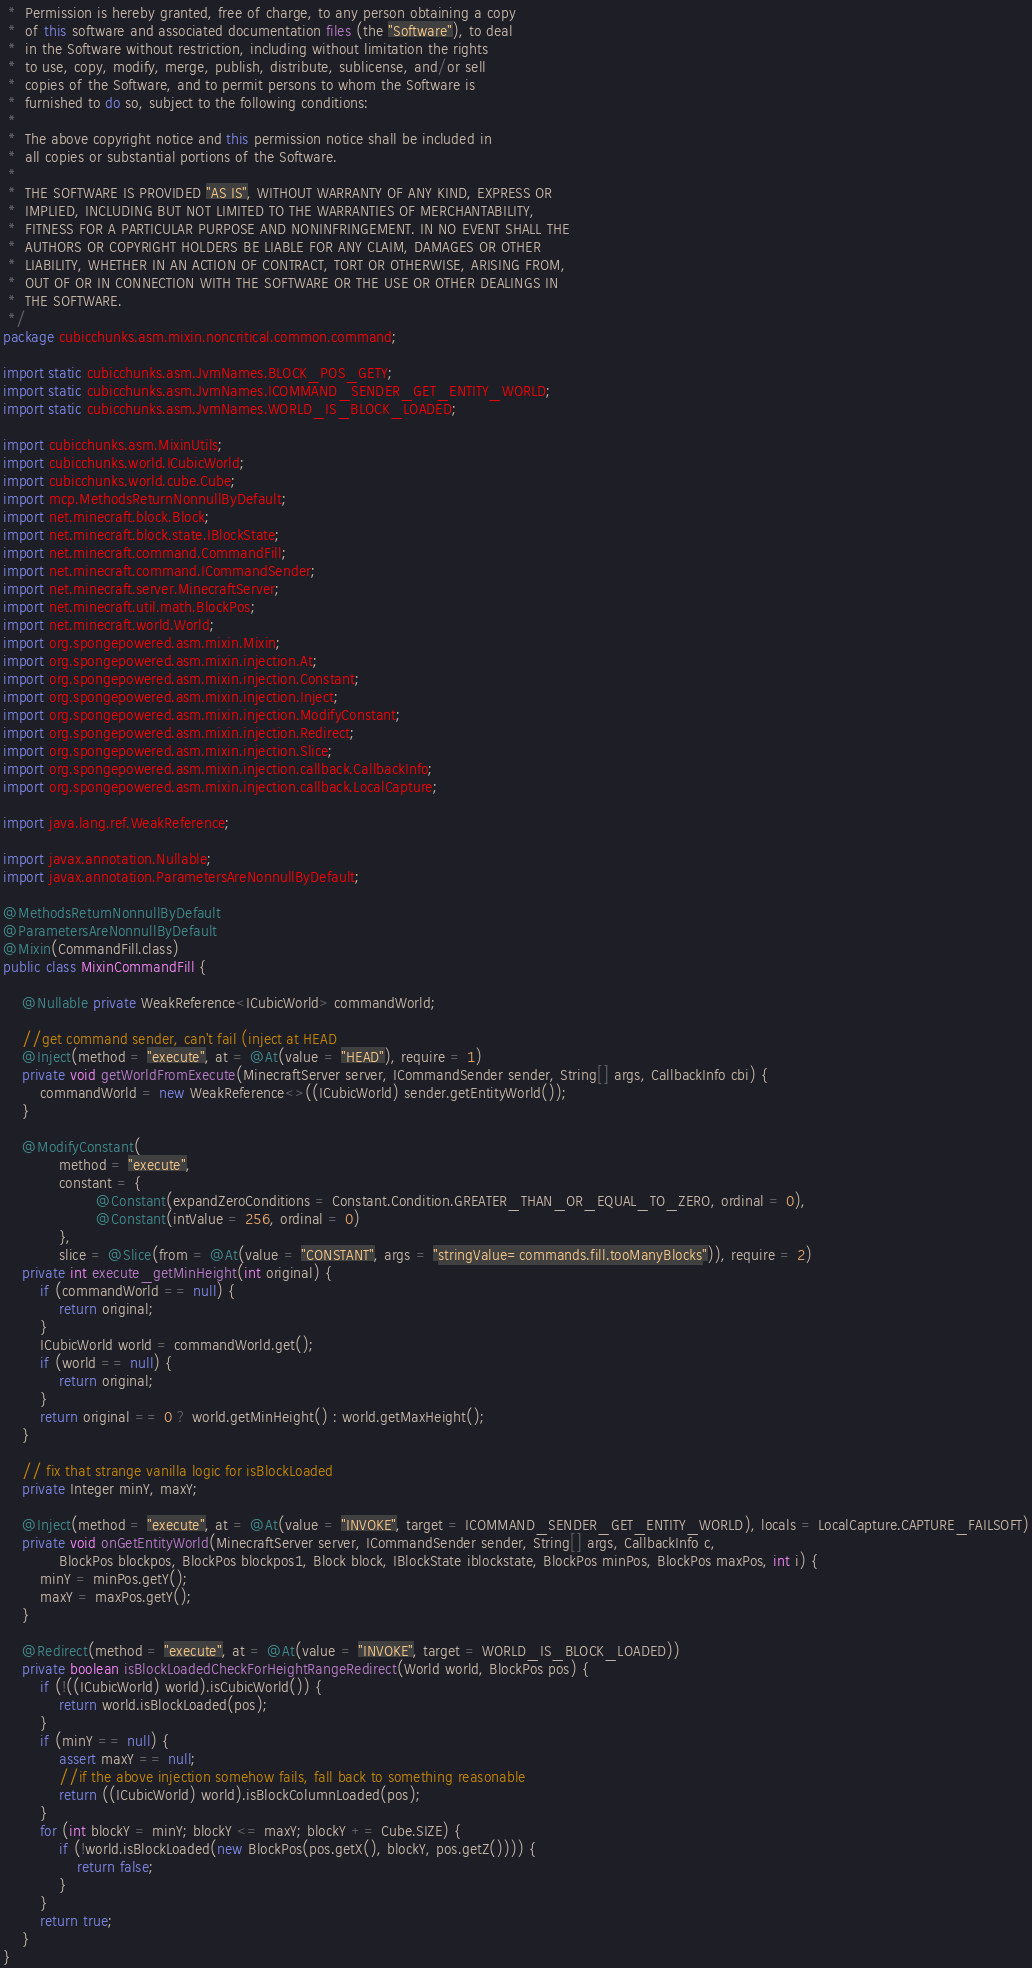<code> <loc_0><loc_0><loc_500><loc_500><_Java_> *  Permission is hereby granted, free of charge, to any person obtaining a copy
 *  of this software and associated documentation files (the "Software"), to deal
 *  in the Software without restriction, including without limitation the rights
 *  to use, copy, modify, merge, publish, distribute, sublicense, and/or sell
 *  copies of the Software, and to permit persons to whom the Software is
 *  furnished to do so, subject to the following conditions:
 *
 *  The above copyright notice and this permission notice shall be included in
 *  all copies or substantial portions of the Software.
 *
 *  THE SOFTWARE IS PROVIDED "AS IS", WITHOUT WARRANTY OF ANY KIND, EXPRESS OR
 *  IMPLIED, INCLUDING BUT NOT LIMITED TO THE WARRANTIES OF MERCHANTABILITY,
 *  FITNESS FOR A PARTICULAR PURPOSE AND NONINFRINGEMENT. IN NO EVENT SHALL THE
 *  AUTHORS OR COPYRIGHT HOLDERS BE LIABLE FOR ANY CLAIM, DAMAGES OR OTHER
 *  LIABILITY, WHETHER IN AN ACTION OF CONTRACT, TORT OR OTHERWISE, ARISING FROM,
 *  OUT OF OR IN CONNECTION WITH THE SOFTWARE OR THE USE OR OTHER DEALINGS IN
 *  THE SOFTWARE.
 */
package cubicchunks.asm.mixin.noncritical.common.command;

import static cubicchunks.asm.JvmNames.BLOCK_POS_GETY;
import static cubicchunks.asm.JvmNames.ICOMMAND_SENDER_GET_ENTITY_WORLD;
import static cubicchunks.asm.JvmNames.WORLD_IS_BLOCK_LOADED;

import cubicchunks.asm.MixinUtils;
import cubicchunks.world.ICubicWorld;
import cubicchunks.world.cube.Cube;
import mcp.MethodsReturnNonnullByDefault;
import net.minecraft.block.Block;
import net.minecraft.block.state.IBlockState;
import net.minecraft.command.CommandFill;
import net.minecraft.command.ICommandSender;
import net.minecraft.server.MinecraftServer;
import net.minecraft.util.math.BlockPos;
import net.minecraft.world.World;
import org.spongepowered.asm.mixin.Mixin;
import org.spongepowered.asm.mixin.injection.At;
import org.spongepowered.asm.mixin.injection.Constant;
import org.spongepowered.asm.mixin.injection.Inject;
import org.spongepowered.asm.mixin.injection.ModifyConstant;
import org.spongepowered.asm.mixin.injection.Redirect;
import org.spongepowered.asm.mixin.injection.Slice;
import org.spongepowered.asm.mixin.injection.callback.CallbackInfo;
import org.spongepowered.asm.mixin.injection.callback.LocalCapture;

import java.lang.ref.WeakReference;

import javax.annotation.Nullable;
import javax.annotation.ParametersAreNonnullByDefault;

@MethodsReturnNonnullByDefault
@ParametersAreNonnullByDefault
@Mixin(CommandFill.class)
public class MixinCommandFill {

    @Nullable private WeakReference<ICubicWorld> commandWorld;

    //get command sender, can't fail (inject at HEAD
    @Inject(method = "execute", at = @At(value = "HEAD"), require = 1)
    private void getWorldFromExecute(MinecraftServer server, ICommandSender sender, String[] args, CallbackInfo cbi) {
        commandWorld = new WeakReference<>((ICubicWorld) sender.getEntityWorld());
    }

    @ModifyConstant(
            method = "execute",
            constant = {
                    @Constant(expandZeroConditions = Constant.Condition.GREATER_THAN_OR_EQUAL_TO_ZERO, ordinal = 0),
                    @Constant(intValue = 256, ordinal = 0)
            },
            slice = @Slice(from = @At(value = "CONSTANT", args = "stringValue=commands.fill.tooManyBlocks")), require = 2)
    private int execute_getMinHeight(int original) {
        if (commandWorld == null) {
            return original;
        }
        ICubicWorld world = commandWorld.get();
        if (world == null) {
            return original;
        }
        return original == 0 ? world.getMinHeight() : world.getMaxHeight();
    }

    // fix that strange vanilla logic for isBlockLoaded
    private Integer minY, maxY;

    @Inject(method = "execute", at = @At(value = "INVOKE", target = ICOMMAND_SENDER_GET_ENTITY_WORLD), locals = LocalCapture.CAPTURE_FAILSOFT)
    private void onGetEntityWorld(MinecraftServer server, ICommandSender sender, String[] args, CallbackInfo c,
            BlockPos blockpos, BlockPos blockpos1, Block block, IBlockState iblockstate, BlockPos minPos, BlockPos maxPos, int i) {
        minY = minPos.getY();
        maxY = maxPos.getY();
    }

    @Redirect(method = "execute", at = @At(value = "INVOKE", target = WORLD_IS_BLOCK_LOADED))
    private boolean isBlockLoadedCheckForHeightRangeRedirect(World world, BlockPos pos) {
        if (!((ICubicWorld) world).isCubicWorld()) {
            return world.isBlockLoaded(pos);
        }
        if (minY == null) {
            assert maxY == null;
            //if the above injection somehow fails, fall back to something reasonable
            return ((ICubicWorld) world).isBlockColumnLoaded(pos);
        }
        for (int blockY = minY; blockY <= maxY; blockY += Cube.SIZE) {
            if (!world.isBlockLoaded(new BlockPos(pos.getX(), blockY, pos.getZ()))) {
                return false;
            }
        }
        return true;
    }
}
</code> 